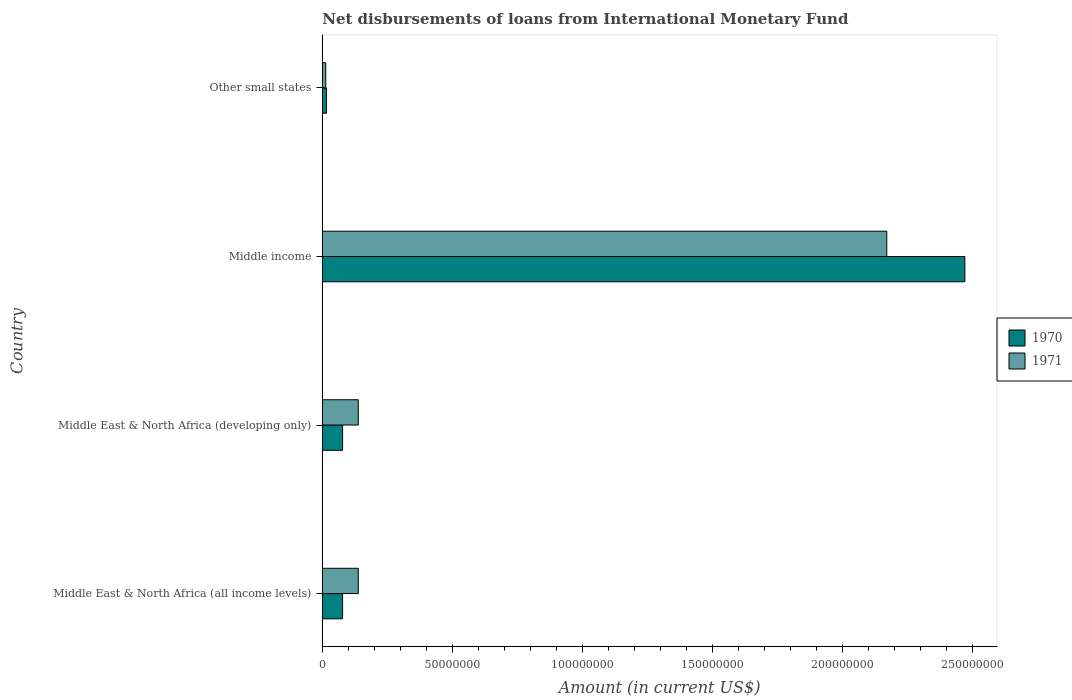How many different coloured bars are there?
Your response must be concise. 2. How many groups of bars are there?
Provide a succinct answer. 4. Are the number of bars on each tick of the Y-axis equal?
Give a very brief answer. Yes. How many bars are there on the 2nd tick from the top?
Your response must be concise. 2. In how many cases, is the number of bars for a given country not equal to the number of legend labels?
Offer a very short reply. 0. What is the amount of loans disbursed in 1971 in Other small states?
Your response must be concise. 1.32e+06. Across all countries, what is the maximum amount of loans disbursed in 1971?
Offer a very short reply. 2.17e+08. Across all countries, what is the minimum amount of loans disbursed in 1971?
Ensure brevity in your answer.  1.32e+06. In which country was the amount of loans disbursed in 1970 maximum?
Provide a succinct answer. Middle income. In which country was the amount of loans disbursed in 1970 minimum?
Give a very brief answer. Other small states. What is the total amount of loans disbursed in 1971 in the graph?
Your answer should be very brief. 2.46e+08. What is the difference between the amount of loans disbursed in 1971 in Middle East & North Africa (all income levels) and that in Other small states?
Provide a succinct answer. 1.25e+07. What is the difference between the amount of loans disbursed in 1971 in Middle East & North Africa (all income levels) and the amount of loans disbursed in 1970 in Other small states?
Your response must be concise. 1.22e+07. What is the average amount of loans disbursed in 1971 per country?
Your answer should be very brief. 6.15e+07. What is the difference between the amount of loans disbursed in 1971 and amount of loans disbursed in 1970 in Other small states?
Your response must be concise. -2.85e+05. In how many countries, is the amount of loans disbursed in 1970 greater than 120000000 US$?
Give a very brief answer. 1. What is the ratio of the amount of loans disbursed in 1970 in Middle East & North Africa (all income levels) to that in Middle East & North Africa (developing only)?
Your response must be concise. 1. What is the difference between the highest and the second highest amount of loans disbursed in 1970?
Keep it short and to the point. 2.39e+08. What is the difference between the highest and the lowest amount of loans disbursed in 1971?
Provide a short and direct response. 2.16e+08. How many bars are there?
Keep it short and to the point. 8. How many countries are there in the graph?
Your answer should be compact. 4. What is the difference between two consecutive major ticks on the X-axis?
Offer a very short reply. 5.00e+07. Are the values on the major ticks of X-axis written in scientific E-notation?
Ensure brevity in your answer.  No. Does the graph contain any zero values?
Your answer should be very brief. No. Where does the legend appear in the graph?
Ensure brevity in your answer.  Center right. What is the title of the graph?
Provide a succinct answer. Net disbursements of loans from International Monetary Fund. What is the label or title of the X-axis?
Provide a short and direct response. Amount (in current US$). What is the Amount (in current US$) of 1970 in Middle East & North Africa (all income levels)?
Offer a very short reply. 7.79e+06. What is the Amount (in current US$) of 1971 in Middle East & North Africa (all income levels)?
Your answer should be very brief. 1.38e+07. What is the Amount (in current US$) in 1970 in Middle East & North Africa (developing only)?
Your answer should be compact. 7.79e+06. What is the Amount (in current US$) of 1971 in Middle East & North Africa (developing only)?
Provide a short and direct response. 1.38e+07. What is the Amount (in current US$) of 1970 in Middle income?
Offer a terse response. 2.47e+08. What is the Amount (in current US$) in 1971 in Middle income?
Your answer should be very brief. 2.17e+08. What is the Amount (in current US$) of 1970 in Other small states?
Give a very brief answer. 1.61e+06. What is the Amount (in current US$) in 1971 in Other small states?
Keep it short and to the point. 1.32e+06. Across all countries, what is the maximum Amount (in current US$) of 1970?
Give a very brief answer. 2.47e+08. Across all countries, what is the maximum Amount (in current US$) in 1971?
Provide a succinct answer. 2.17e+08. Across all countries, what is the minimum Amount (in current US$) in 1970?
Offer a terse response. 1.61e+06. Across all countries, what is the minimum Amount (in current US$) in 1971?
Your answer should be very brief. 1.32e+06. What is the total Amount (in current US$) in 1970 in the graph?
Provide a succinct answer. 2.64e+08. What is the total Amount (in current US$) of 1971 in the graph?
Offer a very short reply. 2.46e+08. What is the difference between the Amount (in current US$) in 1970 in Middle East & North Africa (all income levels) and that in Middle income?
Offer a terse response. -2.39e+08. What is the difference between the Amount (in current US$) in 1971 in Middle East & North Africa (all income levels) and that in Middle income?
Your answer should be compact. -2.03e+08. What is the difference between the Amount (in current US$) in 1970 in Middle East & North Africa (all income levels) and that in Other small states?
Keep it short and to the point. 6.19e+06. What is the difference between the Amount (in current US$) of 1971 in Middle East & North Africa (all income levels) and that in Other small states?
Offer a very short reply. 1.25e+07. What is the difference between the Amount (in current US$) of 1970 in Middle East & North Africa (developing only) and that in Middle income?
Keep it short and to the point. -2.39e+08. What is the difference between the Amount (in current US$) in 1971 in Middle East & North Africa (developing only) and that in Middle income?
Your response must be concise. -2.03e+08. What is the difference between the Amount (in current US$) of 1970 in Middle East & North Africa (developing only) and that in Other small states?
Your answer should be compact. 6.19e+06. What is the difference between the Amount (in current US$) in 1971 in Middle East & North Africa (developing only) and that in Other small states?
Your response must be concise. 1.25e+07. What is the difference between the Amount (in current US$) of 1970 in Middle income and that in Other small states?
Keep it short and to the point. 2.45e+08. What is the difference between the Amount (in current US$) of 1971 in Middle income and that in Other small states?
Your answer should be very brief. 2.16e+08. What is the difference between the Amount (in current US$) of 1970 in Middle East & North Africa (all income levels) and the Amount (in current US$) of 1971 in Middle East & North Africa (developing only)?
Provide a succinct answer. -6.03e+06. What is the difference between the Amount (in current US$) of 1970 in Middle East & North Africa (all income levels) and the Amount (in current US$) of 1971 in Middle income?
Provide a succinct answer. -2.09e+08. What is the difference between the Amount (in current US$) in 1970 in Middle East & North Africa (all income levels) and the Amount (in current US$) in 1971 in Other small states?
Offer a very short reply. 6.47e+06. What is the difference between the Amount (in current US$) of 1970 in Middle East & North Africa (developing only) and the Amount (in current US$) of 1971 in Middle income?
Make the answer very short. -2.09e+08. What is the difference between the Amount (in current US$) of 1970 in Middle East & North Africa (developing only) and the Amount (in current US$) of 1971 in Other small states?
Offer a terse response. 6.47e+06. What is the difference between the Amount (in current US$) of 1970 in Middle income and the Amount (in current US$) of 1971 in Other small states?
Your answer should be compact. 2.46e+08. What is the average Amount (in current US$) in 1970 per country?
Your response must be concise. 6.61e+07. What is the average Amount (in current US$) in 1971 per country?
Make the answer very short. 6.15e+07. What is the difference between the Amount (in current US$) in 1970 and Amount (in current US$) in 1971 in Middle East & North Africa (all income levels)?
Your answer should be very brief. -6.03e+06. What is the difference between the Amount (in current US$) of 1970 and Amount (in current US$) of 1971 in Middle East & North Africa (developing only)?
Offer a very short reply. -6.03e+06. What is the difference between the Amount (in current US$) of 1970 and Amount (in current US$) of 1971 in Middle income?
Offer a terse response. 3.00e+07. What is the difference between the Amount (in current US$) in 1970 and Amount (in current US$) in 1971 in Other small states?
Ensure brevity in your answer.  2.85e+05. What is the ratio of the Amount (in current US$) in 1970 in Middle East & North Africa (all income levels) to that in Middle income?
Offer a terse response. 0.03. What is the ratio of the Amount (in current US$) of 1971 in Middle East & North Africa (all income levels) to that in Middle income?
Offer a terse response. 0.06. What is the ratio of the Amount (in current US$) of 1970 in Middle East & North Africa (all income levels) to that in Other small states?
Offer a terse response. 4.85. What is the ratio of the Amount (in current US$) of 1971 in Middle East & North Africa (all income levels) to that in Other small states?
Make the answer very short. 10.45. What is the ratio of the Amount (in current US$) of 1970 in Middle East & North Africa (developing only) to that in Middle income?
Give a very brief answer. 0.03. What is the ratio of the Amount (in current US$) in 1971 in Middle East & North Africa (developing only) to that in Middle income?
Ensure brevity in your answer.  0.06. What is the ratio of the Amount (in current US$) in 1970 in Middle East & North Africa (developing only) to that in Other small states?
Make the answer very short. 4.85. What is the ratio of the Amount (in current US$) in 1971 in Middle East & North Africa (developing only) to that in Other small states?
Your answer should be very brief. 10.45. What is the ratio of the Amount (in current US$) in 1970 in Middle income to that in Other small states?
Offer a terse response. 153.71. What is the ratio of the Amount (in current US$) of 1971 in Middle income to that in Other small states?
Offer a terse response. 164.14. What is the difference between the highest and the second highest Amount (in current US$) of 1970?
Make the answer very short. 2.39e+08. What is the difference between the highest and the second highest Amount (in current US$) in 1971?
Your answer should be compact. 2.03e+08. What is the difference between the highest and the lowest Amount (in current US$) of 1970?
Your answer should be very brief. 2.45e+08. What is the difference between the highest and the lowest Amount (in current US$) of 1971?
Provide a succinct answer. 2.16e+08. 